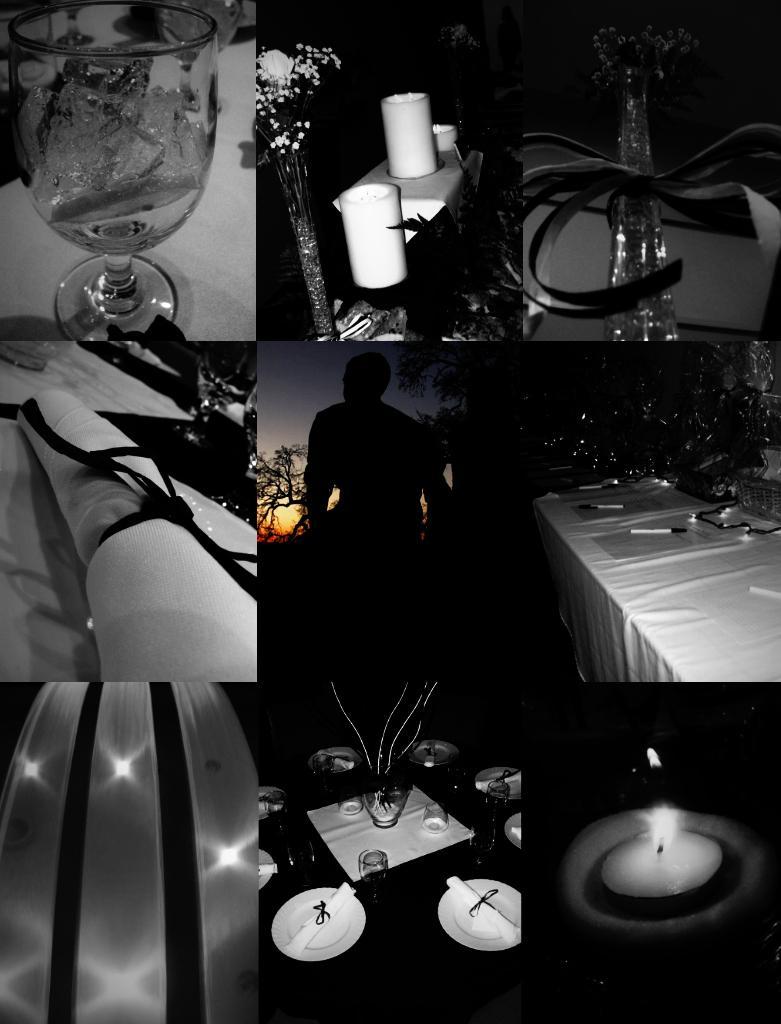Describe this image in one or two sentences. This photo graph deals with the college of nine photos in it, First is a water glass photo, second with candle in the tray, Middle shows a person standing and seeing to the sunset. And in the down we can see a dining table with and papers on it. 